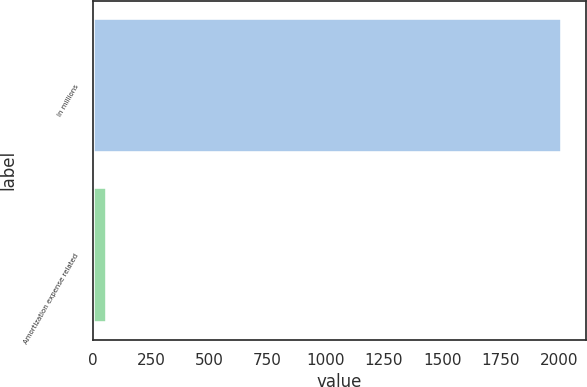Convert chart to OTSL. <chart><loc_0><loc_0><loc_500><loc_500><bar_chart><fcel>In millions<fcel>Amortization expense related<nl><fcel>2015<fcel>60<nl></chart> 